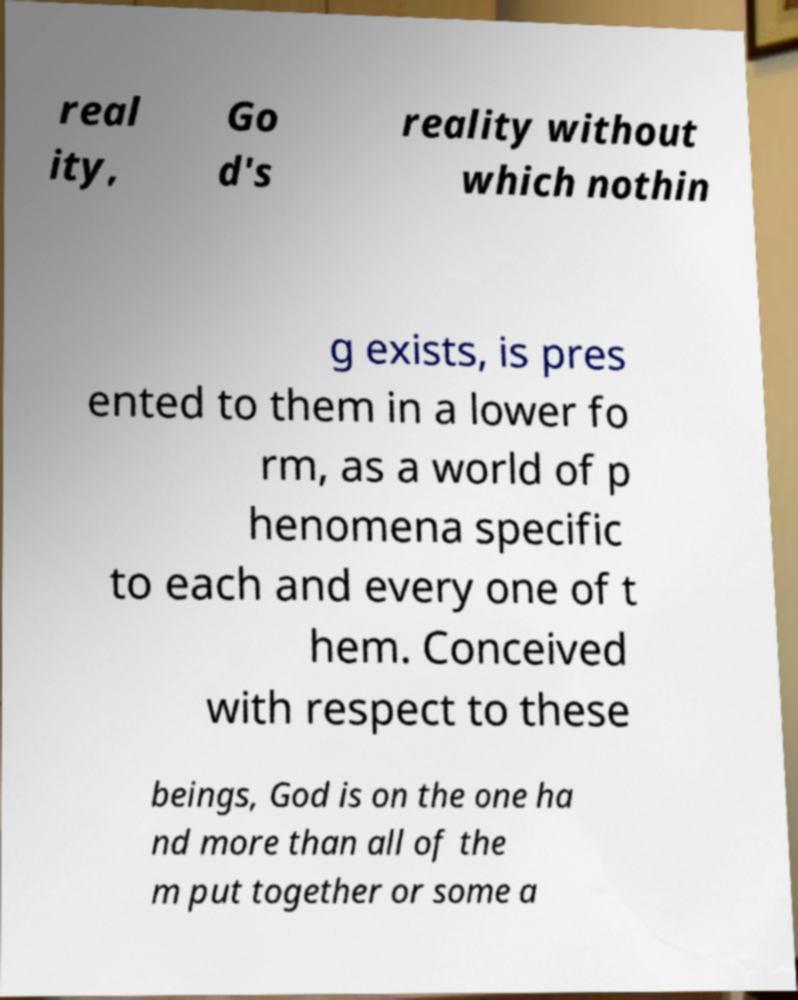Can you accurately transcribe the text from the provided image for me? real ity, Go d's reality without which nothin g exists, is pres ented to them in a lower fo rm, as a world of p henomena specific to each and every one of t hem. Conceived with respect to these beings, God is on the one ha nd more than all of the m put together or some a 